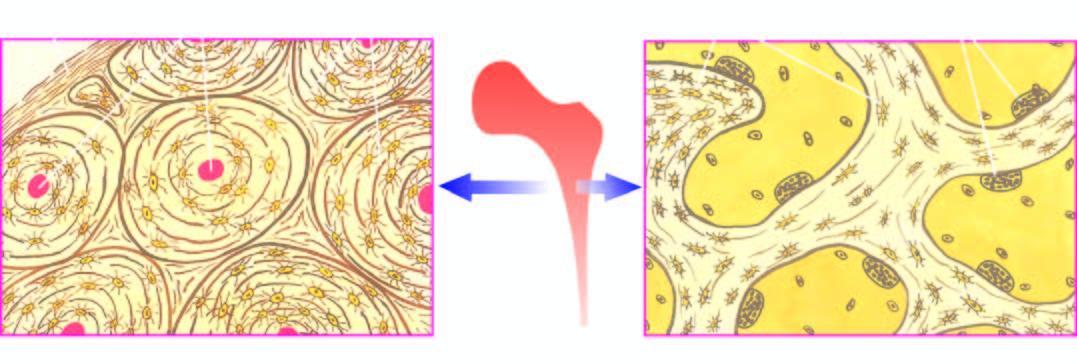does the cortical bone forming the outer shell show concentric lamellae along with osteocytic lacunae surrounding central blood vessels, while the trabecular bone forming the marrow space shows trabeculae with osteoclastic activity at the margins?
Answer the question using a single word or phrase. Yes 